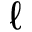Convert formula to latex. <formula><loc_0><loc_0><loc_500><loc_500>\ell</formula> 